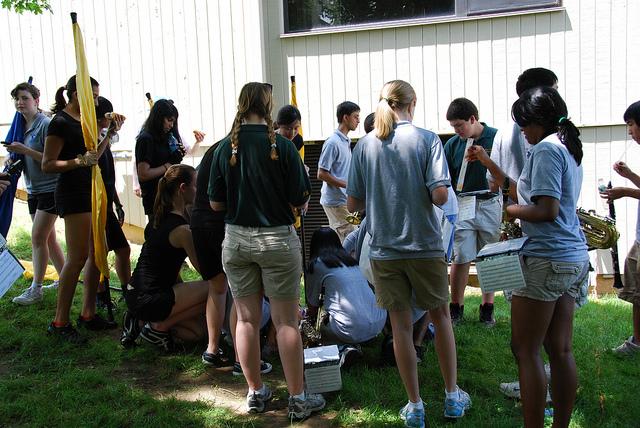What are the people standing on?
Short answer required. Grass. What color flag is the girl on the left wearing?
Answer briefly. Yellow. What kind of flag is in the background?
Answer briefly. Yellow. How many out of fifteen people are male?
Give a very brief answer. 3. 